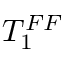<formula> <loc_0><loc_0><loc_500><loc_500>T _ { 1 } ^ { F F }</formula> 